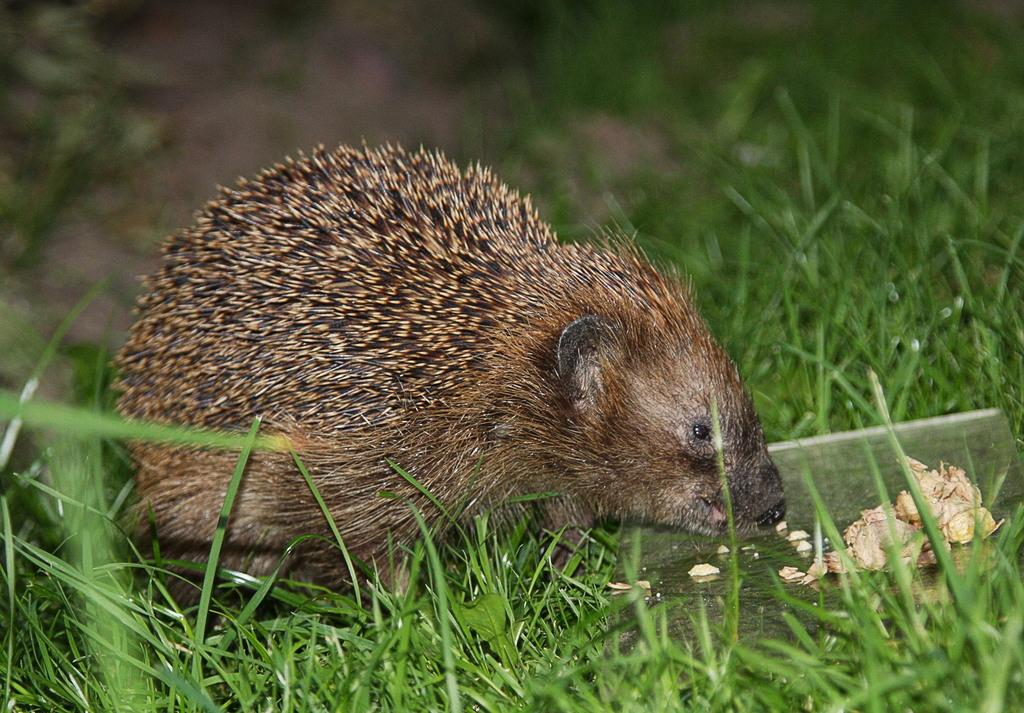What type of animal is in the image? There is an animal in the image, but the specific type cannot be determined from the provided facts. Where is the animal located in the image? The animal is on the grass in the image. What can be said about the background of the image? The background of the image is blurred. How many kittens are playing in the country in the image? There is no information about kittens or a country in the image, so this question cannot be answered definitively. 